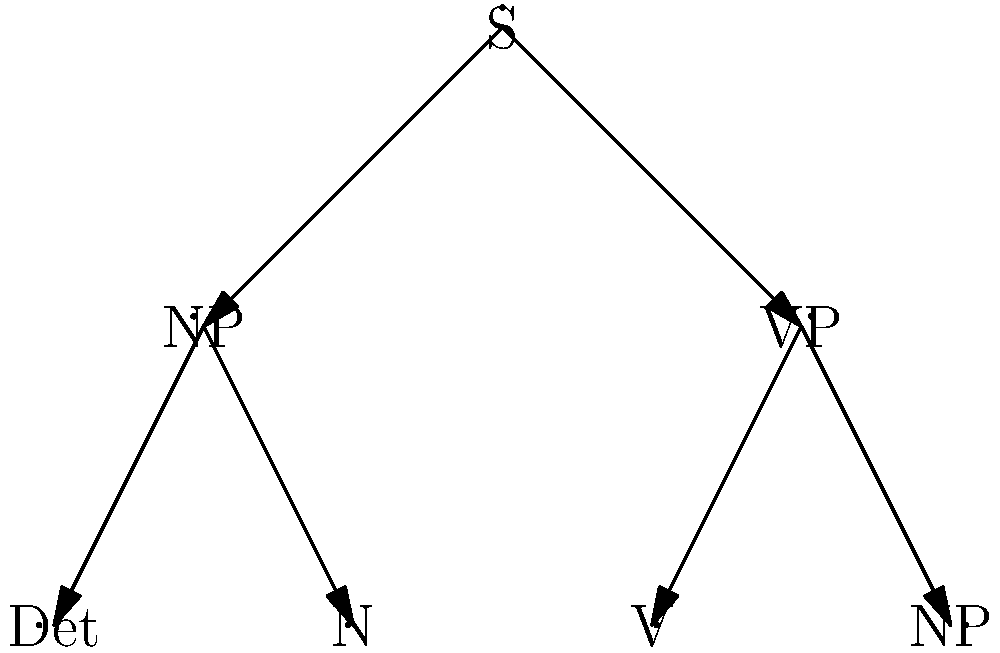Given the parse tree above, which represents a simplified structure for a sentence in English, what is the maximum depth of this tree, and how does this relate to the concept of linguistic complexity in natural language processing? To answer this question, we need to analyze the parse tree and understand its implications for linguistic complexity:

1. Tree depth analysis:
   - The root node is S (Sentence)
   - Level 1: NP (Noun Phrase) and VP (Verb Phrase)
   - Level 2: Det (Determiner), N (Noun), V (Verb), and NP (Noun Phrase)
   - The maximum depth is 3 levels (including the root)

2. Linguistic complexity:
   - Tree depth often correlates with sentence complexity
   - Deeper trees usually represent more complex syntactic structures
   - However, depth alone is not a complete measure of complexity

3. Relevance to natural language processing:
   - Parse trees are used in NLP for syntactic analysis
   - They help in understanding sentence structure and relationships between words
   - More complex sentences often require more computational resources to parse

4. Limitations of this representation:
   - This tree is simplified and doesn't show all linguistic details
   - Real-world sentences can have much deeper and more complex structures
   - Some linguistic phenomena (e.g., long-distance dependencies) are not captured

5. Computational linguistics perspective:
   - While useful, parse trees are just one way to represent linguistic structure
   - They don't capture semantic nuances or pragmatic aspects of language
   - More sophisticated models (e.g., neural networks) can capture additional complexities

6. Relation to the persona's view on chess and intelligence:
   - Like chess, this parse tree is a simplified model of language structure
   - It doesn't capture the full complexity of natural language or human cognition
   - More advanced NLP models attempt to address these limitations

In conclusion, while the maximum depth of 3 in this tree indicates a relatively simple sentence structure, it's important to recognize that linguistic complexity goes beyond mere tree depth and that parse trees, like chess, are useful but limited models of their respective domains.
Answer: Maximum depth: 3. While indicative of syntactic structure, tree depth alone is an oversimplified measure of linguistic complexity, much like how chess models only limited aspects of intelligence. 